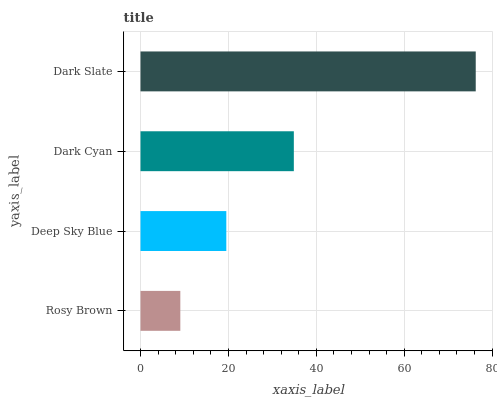Is Rosy Brown the minimum?
Answer yes or no. Yes. Is Dark Slate the maximum?
Answer yes or no. Yes. Is Deep Sky Blue the minimum?
Answer yes or no. No. Is Deep Sky Blue the maximum?
Answer yes or no. No. Is Deep Sky Blue greater than Rosy Brown?
Answer yes or no. Yes. Is Rosy Brown less than Deep Sky Blue?
Answer yes or no. Yes. Is Rosy Brown greater than Deep Sky Blue?
Answer yes or no. No. Is Deep Sky Blue less than Rosy Brown?
Answer yes or no. No. Is Dark Cyan the high median?
Answer yes or no. Yes. Is Deep Sky Blue the low median?
Answer yes or no. Yes. Is Rosy Brown the high median?
Answer yes or no. No. Is Dark Slate the low median?
Answer yes or no. No. 